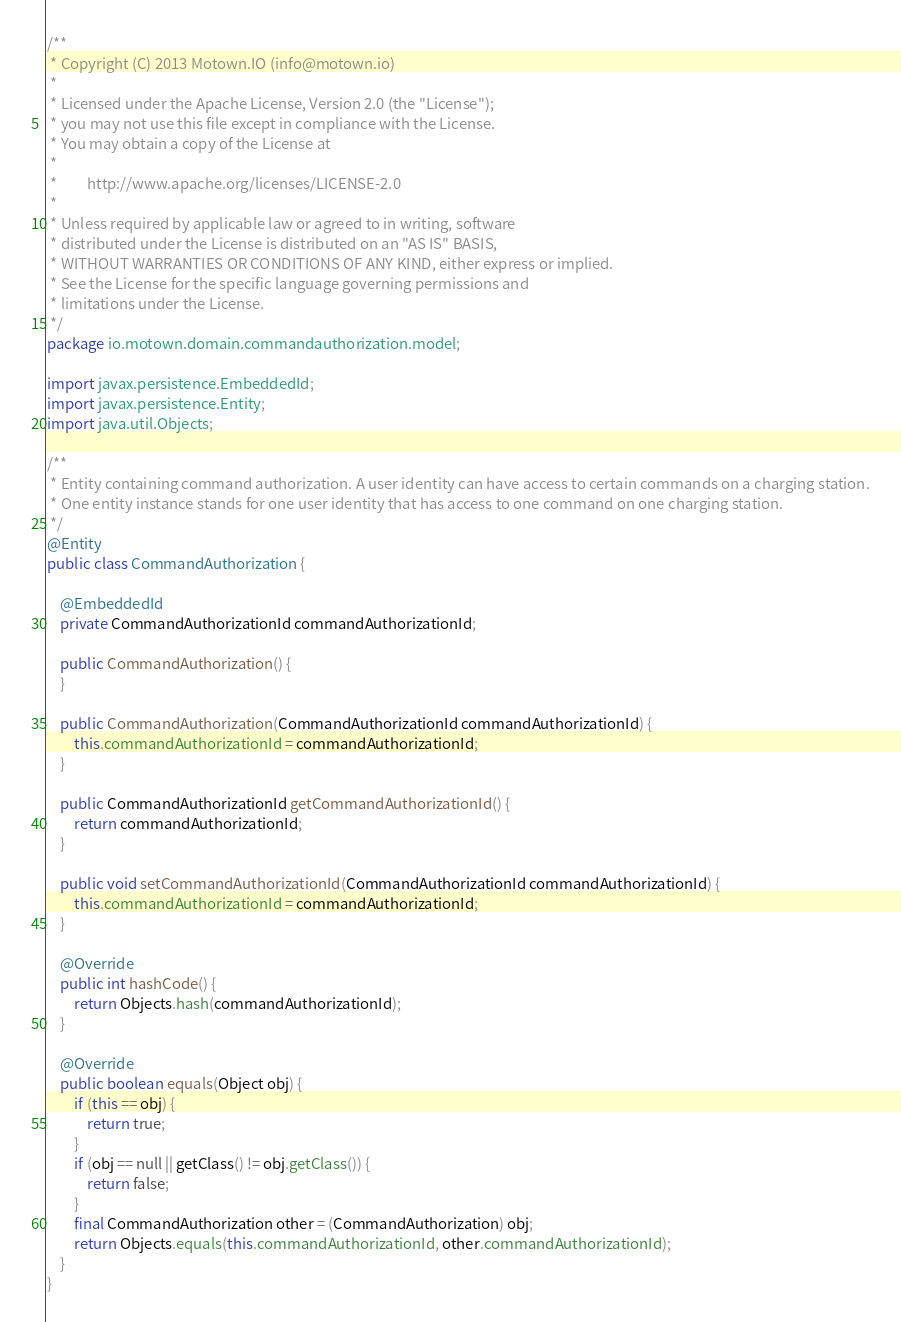<code> <loc_0><loc_0><loc_500><loc_500><_Java_>/**
 * Copyright (C) 2013 Motown.IO (info@motown.io)
 *
 * Licensed under the Apache License, Version 2.0 (the "License");
 * you may not use this file except in compliance with the License.
 * You may obtain a copy of the License at
 *
 *         http://www.apache.org/licenses/LICENSE-2.0
 *
 * Unless required by applicable law or agreed to in writing, software
 * distributed under the License is distributed on an "AS IS" BASIS,
 * WITHOUT WARRANTIES OR CONDITIONS OF ANY KIND, either express or implied.
 * See the License for the specific language governing permissions and
 * limitations under the License.
 */
package io.motown.domain.commandauthorization.model;

import javax.persistence.EmbeddedId;
import javax.persistence.Entity;
import java.util.Objects;

/**
 * Entity containing command authorization. A user identity can have access to certain commands on a charging station.
 * One entity instance stands for one user identity that has access to one command on one charging station.
 */
@Entity
public class CommandAuthorization {

    @EmbeddedId
    private CommandAuthorizationId commandAuthorizationId;

    public CommandAuthorization() {
    }

    public CommandAuthorization(CommandAuthorizationId commandAuthorizationId) {
        this.commandAuthorizationId = commandAuthorizationId;
    }

    public CommandAuthorizationId getCommandAuthorizationId() {
        return commandAuthorizationId;
    }

    public void setCommandAuthorizationId(CommandAuthorizationId commandAuthorizationId) {
        this.commandAuthorizationId = commandAuthorizationId;
    }

    @Override
    public int hashCode() {
        return Objects.hash(commandAuthorizationId);
    }

    @Override
    public boolean equals(Object obj) {
        if (this == obj) {
            return true;
        }
        if (obj == null || getClass() != obj.getClass()) {
            return false;
        }
        final CommandAuthorization other = (CommandAuthorization) obj;
        return Objects.equals(this.commandAuthorizationId, other.commandAuthorizationId);
    }
}
</code> 